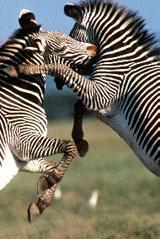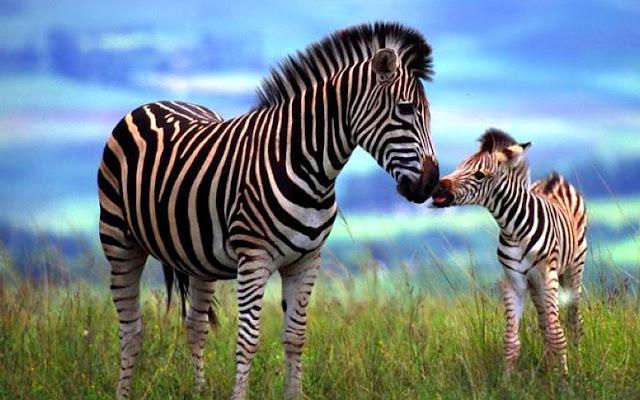The first image is the image on the left, the second image is the image on the right. For the images displayed, is the sentence "In at least one image there is a mother and calf zebra touching noses." factually correct? Answer yes or no. Yes. The first image is the image on the left, the second image is the image on the right. For the images displayed, is the sentence "One image shows two zebras face-to-face and standing upright with their heads crossed." factually correct? Answer yes or no. Yes. 